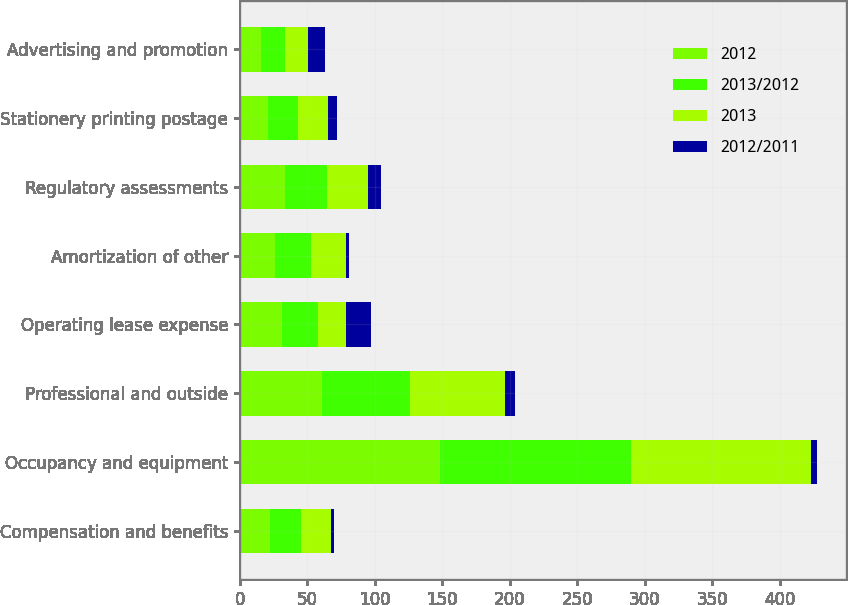Convert chart. <chart><loc_0><loc_0><loc_500><loc_500><stacked_bar_chart><ecel><fcel>Compensation and benefits<fcel>Occupancy and equipment<fcel>Professional and outside<fcel>Operating lease expense<fcel>Amortization of other<fcel>Regulatory assessments<fcel>Stationery printing postage<fcel>Advertising and promotion<nl><fcel>2012<fcel>22.5<fcel>148<fcel>60.6<fcel>31.3<fcel>26.2<fcel>33.8<fcel>20.9<fcel>15.4<nl><fcel>2013/2012<fcel>22.5<fcel>141.9<fcel>65.4<fcel>26.3<fcel>26.8<fcel>30.8<fcel>22.5<fcel>17.7<nl><fcel>2013<fcel>22.5<fcel>133.3<fcel>70.6<fcel>20.8<fcel>25.8<fcel>30.1<fcel>21.6<fcel>17.2<nl><fcel>2012/2011<fcel>2<fcel>4.3<fcel>7.3<fcel>19<fcel>2.2<fcel>9.7<fcel>7.1<fcel>13<nl></chart> 